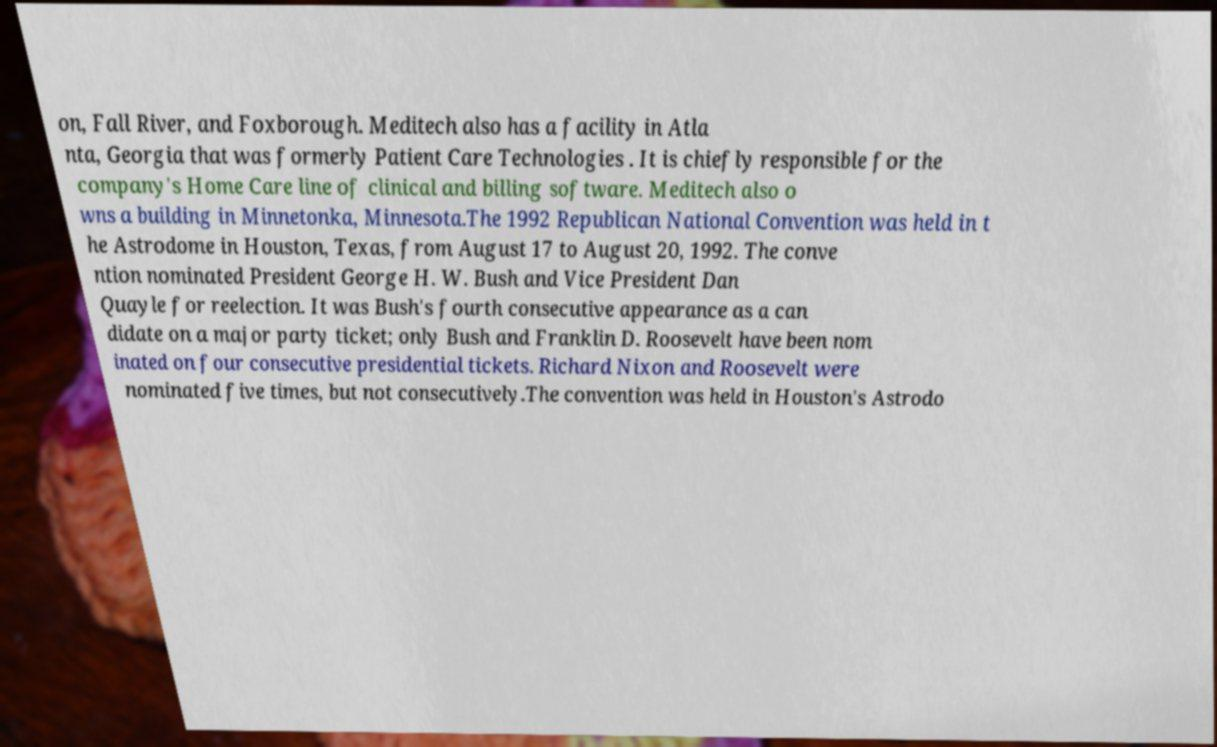Can you accurately transcribe the text from the provided image for me? on, Fall River, and Foxborough. Meditech also has a facility in Atla nta, Georgia that was formerly Patient Care Technologies . It is chiefly responsible for the company's Home Care line of clinical and billing software. Meditech also o wns a building in Minnetonka, Minnesota.The 1992 Republican National Convention was held in t he Astrodome in Houston, Texas, from August 17 to August 20, 1992. The conve ntion nominated President George H. W. Bush and Vice President Dan Quayle for reelection. It was Bush's fourth consecutive appearance as a can didate on a major party ticket; only Bush and Franklin D. Roosevelt have been nom inated on four consecutive presidential tickets. Richard Nixon and Roosevelt were nominated five times, but not consecutively.The convention was held in Houston's Astrodo 